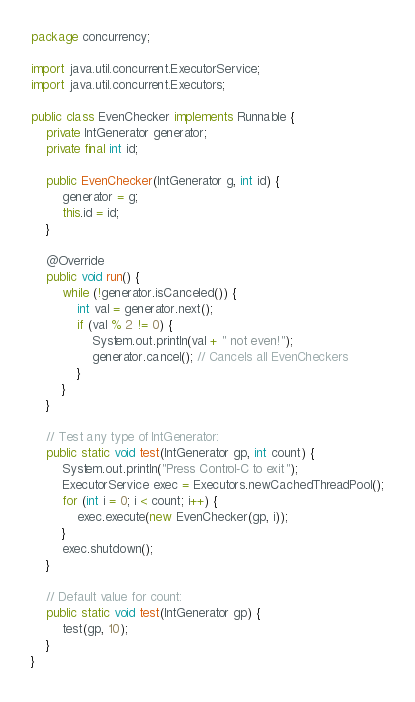Convert code to text. <code><loc_0><loc_0><loc_500><loc_500><_Java_>package concurrency;

import java.util.concurrent.ExecutorService;
import java.util.concurrent.Executors;

public class EvenChecker implements Runnable {
    private IntGenerator generator;
    private final int id;

    public EvenChecker(IntGenerator g, int id) {
        generator = g;
        this.id = id;
    }

    @Override
    public void run() {
        while (!generator.isCanceled()) {
            int val = generator.next();
            if (val % 2 != 0) {
                System.out.println(val + " not even!");
                generator.cancel(); // Cancels all EvenCheckers
            }
        }
    }

    // Test any type of IntGenerator:
    public static void test(IntGenerator gp, int count) {
        System.out.println("Press Control-C to exit");
        ExecutorService exec = Executors.newCachedThreadPool();
        for (int i = 0; i < count; i++) {
            exec.execute(new EvenChecker(gp, i));
        }
        exec.shutdown();
    }

    // Default value for count:
    public static void test(IntGenerator gp) {
        test(gp, 10);
    }
}
</code> 